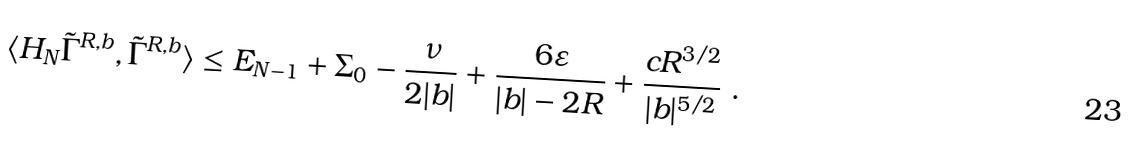<formula> <loc_0><loc_0><loc_500><loc_500>\langle H _ { N } \tilde { \Gamma } ^ { R , b } , \tilde { \Gamma } ^ { R , b } \rangle \leq E _ { N - 1 } + \Sigma _ { 0 } - \frac { \nu } { 2 | b | } + \frac { 6 \varepsilon } { | b | - 2 R } + \frac { c R ^ { 3 / 2 } } { | b | ^ { 5 / 2 } } \ .</formula> 